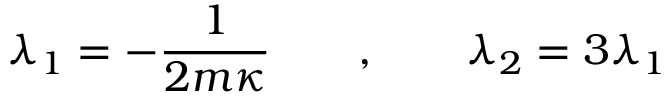Convert formula to latex. <formula><loc_0><loc_0><loc_500><loc_500>\lambda _ { 1 } = - { \frac { 1 } { 2 m \kappa } } \quad , \quad \lambda _ { 2 } = 3 \lambda _ { 1 }</formula> 